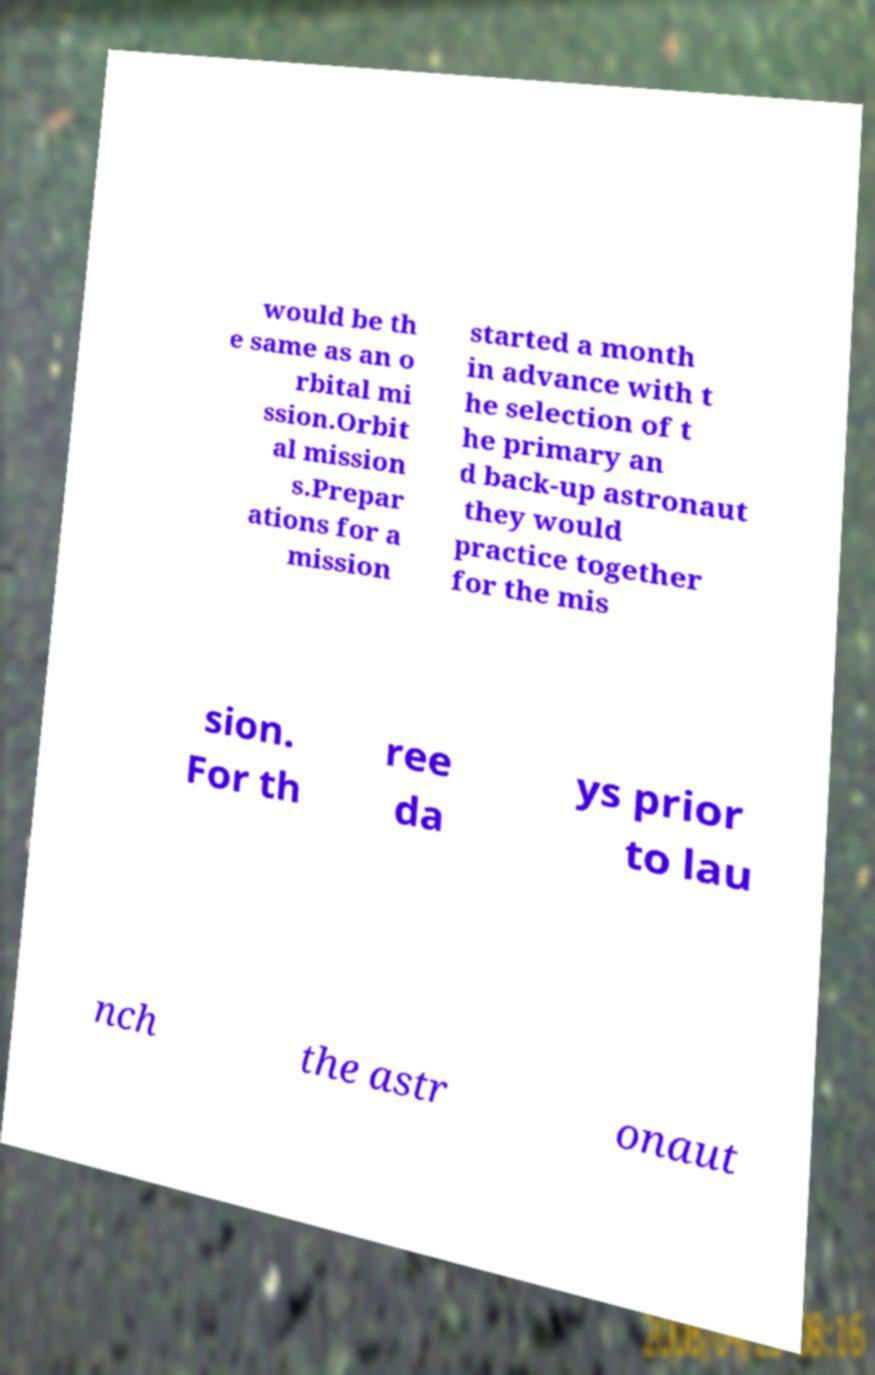What messages or text are displayed in this image? I need them in a readable, typed format. would be th e same as an o rbital mi ssion.Orbit al mission s.Prepar ations for a mission started a month in advance with t he selection of t he primary an d back-up astronaut they would practice together for the mis sion. For th ree da ys prior to lau nch the astr onaut 